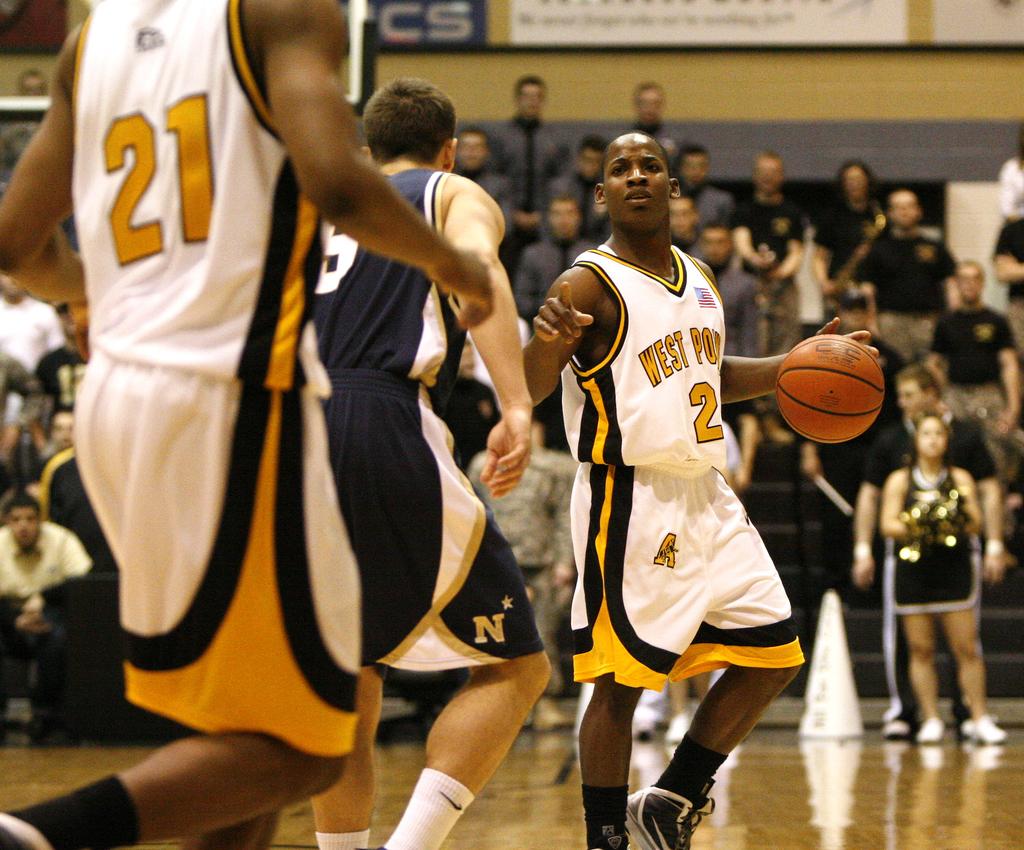What number is the player with the ball?
Your answer should be very brief. 2. What number is the player to the left?
Keep it short and to the point. 21. 